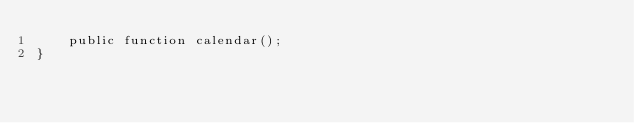Convert code to text. <code><loc_0><loc_0><loc_500><loc_500><_PHP_>    public function calendar();
}
</code> 